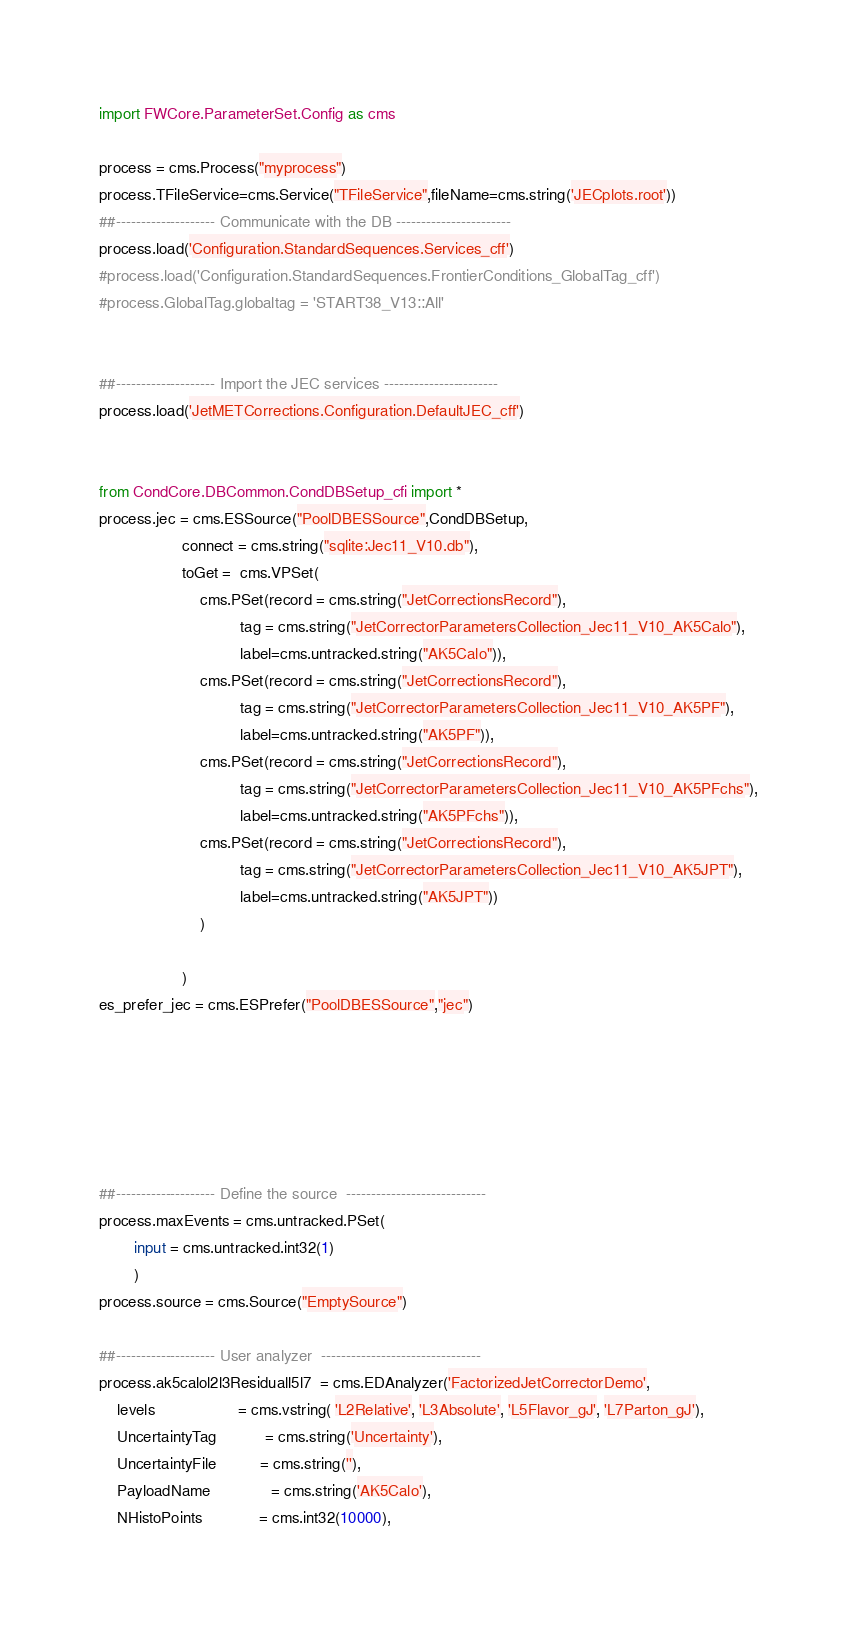<code> <loc_0><loc_0><loc_500><loc_500><_Python_>import FWCore.ParameterSet.Config as cms

process = cms.Process("myprocess")
process.TFileService=cms.Service("TFileService",fileName=cms.string('JECplots.root'))
##-------------------- Communicate with the DB -----------------------
process.load('Configuration.StandardSequences.Services_cff')
#process.load('Configuration.StandardSequences.FrontierConditions_GlobalTag_cff')
#process.GlobalTag.globaltag = 'START38_V13::All'


##-------------------- Import the JEC services -----------------------
process.load('JetMETCorrections.Configuration.DefaultJEC_cff')


from CondCore.DBCommon.CondDBSetup_cfi import *
process.jec = cms.ESSource("PoolDBESSource",CondDBSetup,
                   connect = cms.string("sqlite:Jec11_V10.db"),
                   toGet =  cms.VPSet(
                       cms.PSet(record = cms.string("JetCorrectionsRecord"),
                                tag = cms.string("JetCorrectorParametersCollection_Jec11_V10_AK5Calo"),
                                label=cms.untracked.string("AK5Calo")),
                       cms.PSet(record = cms.string("JetCorrectionsRecord"),
                                tag = cms.string("JetCorrectorParametersCollection_Jec11_V10_AK5PF"),
                                label=cms.untracked.string("AK5PF")),
                       cms.PSet(record = cms.string("JetCorrectionsRecord"),
                                tag = cms.string("JetCorrectorParametersCollection_Jec11_V10_AK5PFchs"),
                                label=cms.untracked.string("AK5PFchs")),
                       cms.PSet(record = cms.string("JetCorrectionsRecord"),
                                tag = cms.string("JetCorrectorParametersCollection_Jec11_V10_AK5JPT"),
                                label=cms.untracked.string("AK5JPT"))
                       )
                   
                   )
es_prefer_jec = cms.ESPrefer("PoolDBESSource","jec")






##-------------------- Define the source  ----------------------------
process.maxEvents = cms.untracked.PSet(
        input = cms.untracked.int32(1)
        )
process.source = cms.Source("EmptySource")

##-------------------- User analyzer  --------------------------------
process.ak5calol2l3Residuall5l7  = cms.EDAnalyzer('FactorizedJetCorrectorDemo',
    levels                   = cms.vstring( 'L2Relative', 'L3Absolute', 'L5Flavor_gJ', 'L7Parton_gJ'),
    UncertaintyTag           = cms.string('Uncertainty'),
    UncertaintyFile          = cms.string(''),
    PayloadName              = cms.string('AK5Calo'),
    NHistoPoints             = cms.int32(10000),</code> 